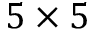<formula> <loc_0><loc_0><loc_500><loc_500>5 \times 5</formula> 